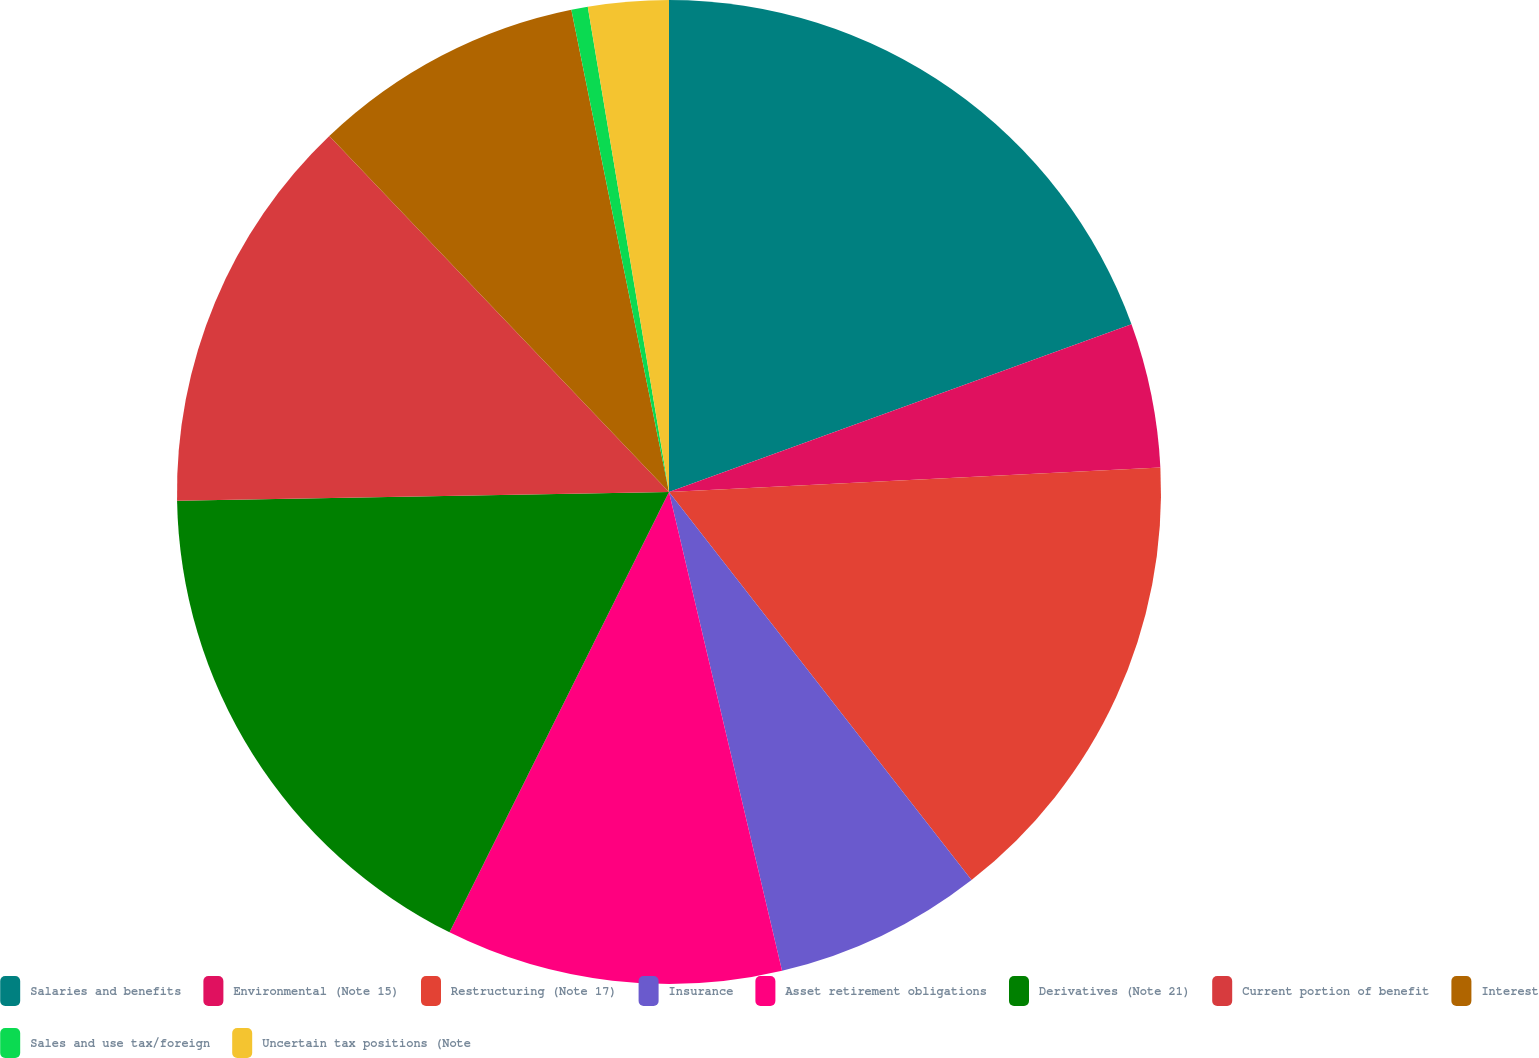<chart> <loc_0><loc_0><loc_500><loc_500><pie_chart><fcel>Salaries and benefits<fcel>Environmental (Note 15)<fcel>Restructuring (Note 17)<fcel>Insurance<fcel>Asset retirement obligations<fcel>Derivatives (Note 21)<fcel>Current portion of benefit<fcel>Interest<fcel>Sales and use tax/foreign<fcel>Uncertain tax positions (Note<nl><fcel>19.46%<fcel>4.75%<fcel>15.25%<fcel>6.85%<fcel>11.05%<fcel>17.36%<fcel>13.15%<fcel>8.95%<fcel>0.54%<fcel>2.64%<nl></chart> 